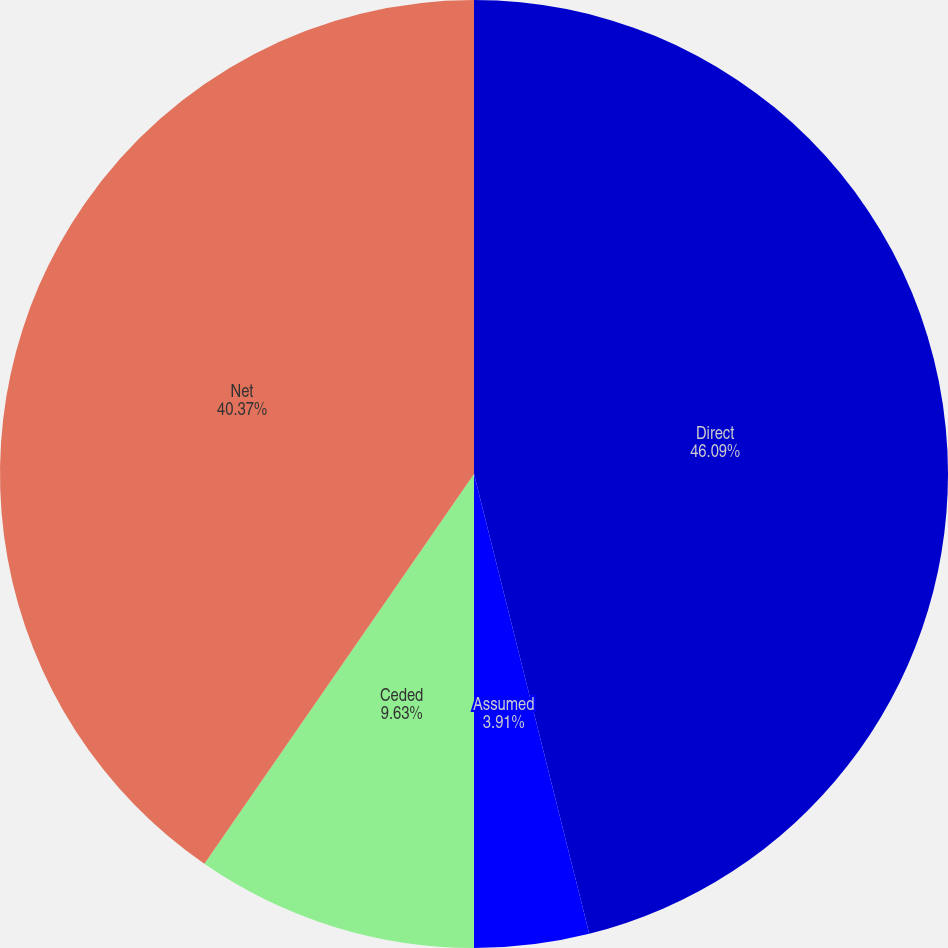<chart> <loc_0><loc_0><loc_500><loc_500><pie_chart><fcel>Direct<fcel>Assumed<fcel>Ceded<fcel>Net<nl><fcel>46.09%<fcel>3.91%<fcel>9.63%<fcel>40.37%<nl></chart> 